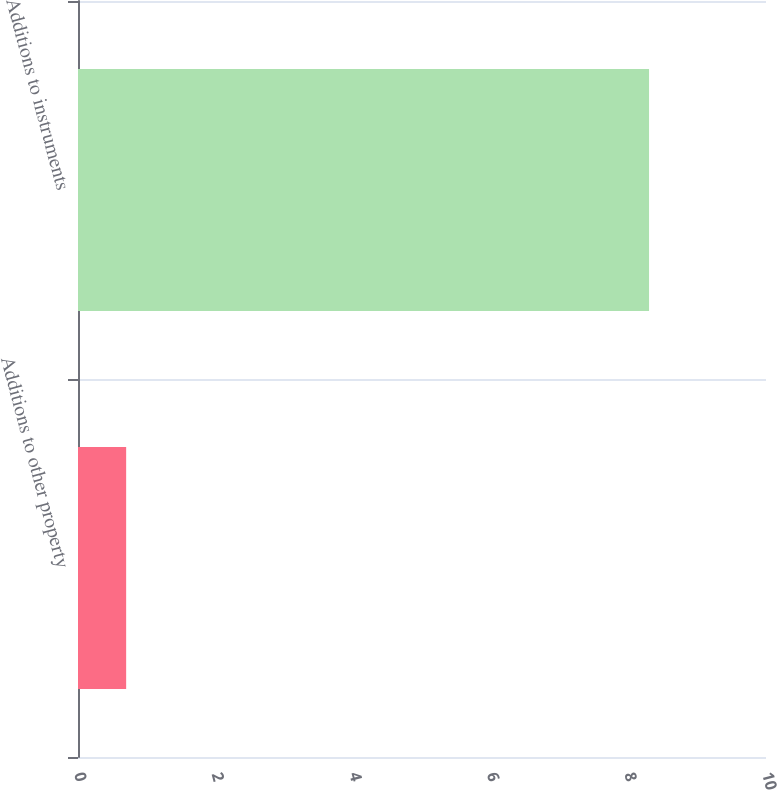Convert chart. <chart><loc_0><loc_0><loc_500><loc_500><bar_chart><fcel>Additions to other property<fcel>Additions to instruments<nl><fcel>0.7<fcel>8.3<nl></chart> 